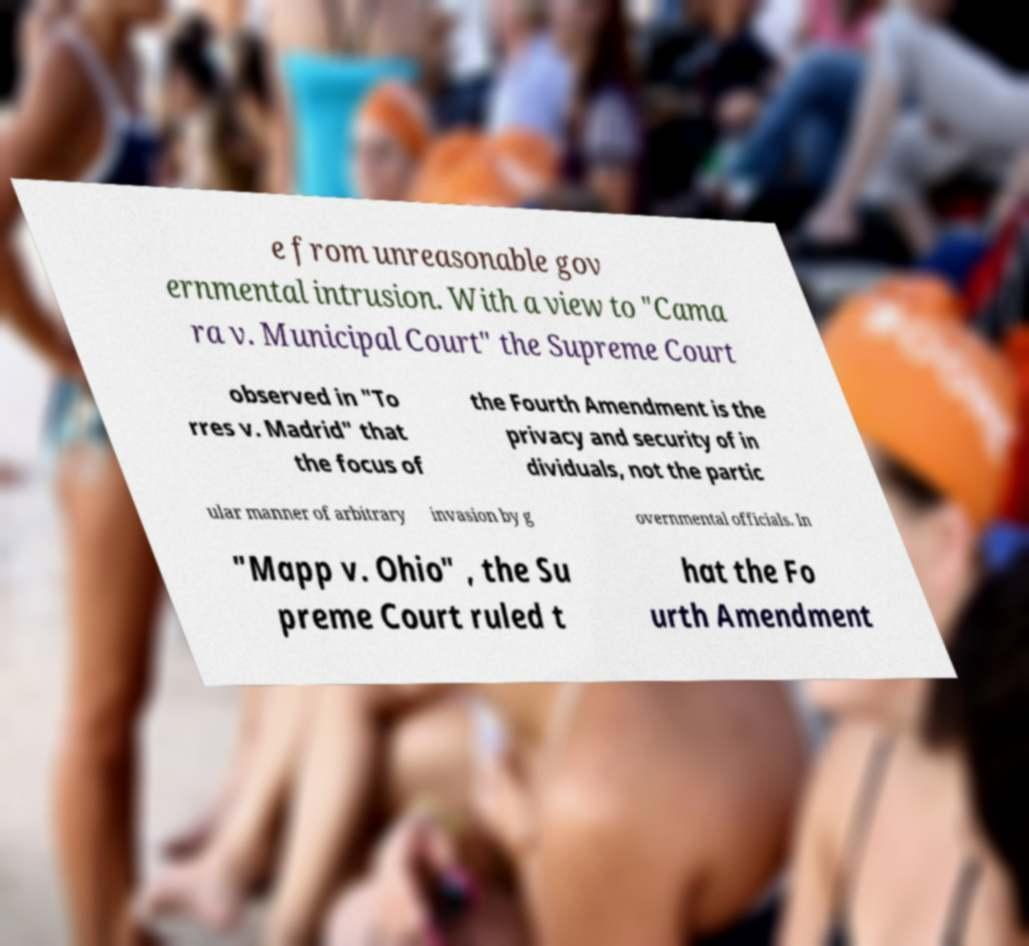There's text embedded in this image that I need extracted. Can you transcribe it verbatim? e from unreasonable gov ernmental intrusion. With a view to "Cama ra v. Municipal Court" the Supreme Court observed in "To rres v. Madrid" that the focus of the Fourth Amendment is the privacy and security of in dividuals, not the partic ular manner of arbitrary invasion by g overnmental officials. In "Mapp v. Ohio" , the Su preme Court ruled t hat the Fo urth Amendment 